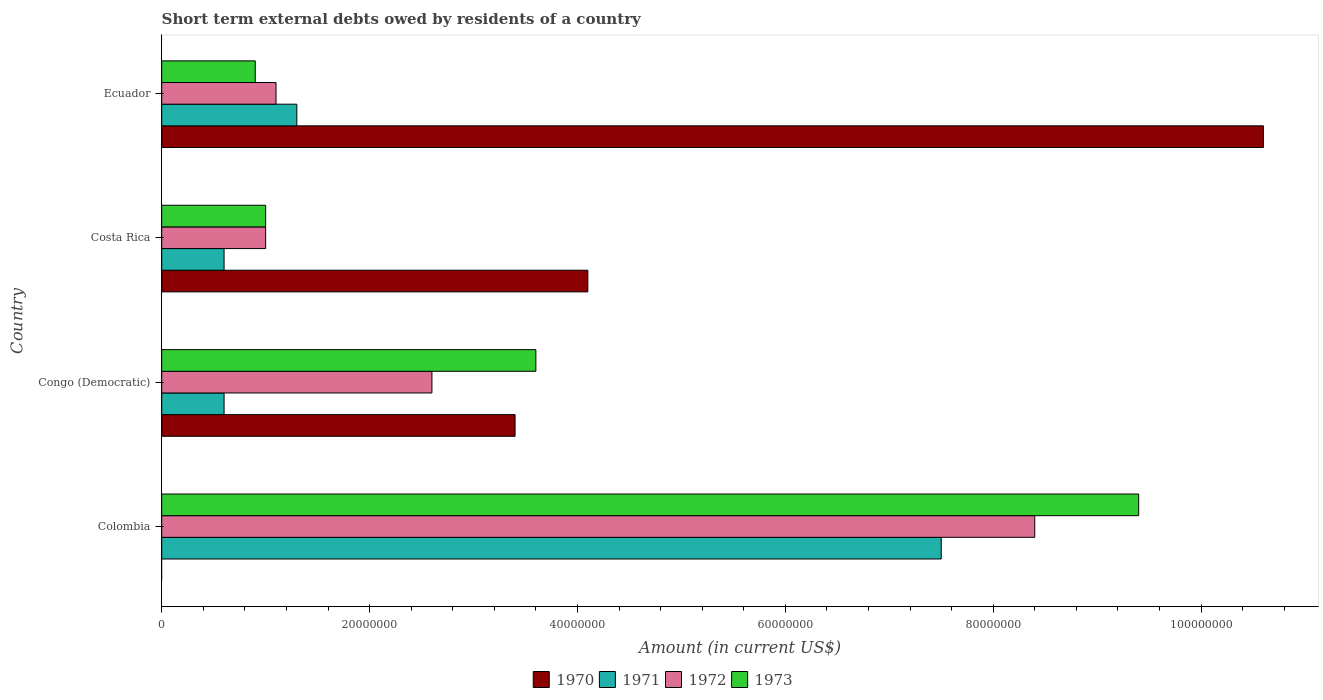How many groups of bars are there?
Provide a short and direct response. 4. What is the label of the 1st group of bars from the top?
Give a very brief answer. Ecuador. What is the amount of short-term external debts owed by residents in 1971 in Ecuador?
Your answer should be very brief. 1.30e+07. Across all countries, what is the maximum amount of short-term external debts owed by residents in 1970?
Provide a short and direct response. 1.06e+08. In which country was the amount of short-term external debts owed by residents in 1973 maximum?
Make the answer very short. Colombia. What is the total amount of short-term external debts owed by residents in 1970 in the graph?
Offer a very short reply. 1.81e+08. What is the difference between the amount of short-term external debts owed by residents in 1970 in Costa Rica and that in Ecuador?
Make the answer very short. -6.50e+07. What is the difference between the amount of short-term external debts owed by residents in 1973 in Colombia and the amount of short-term external debts owed by residents in 1972 in Costa Rica?
Provide a succinct answer. 8.40e+07. What is the average amount of short-term external debts owed by residents in 1971 per country?
Your response must be concise. 2.50e+07. What is the difference between the amount of short-term external debts owed by residents in 1971 and amount of short-term external debts owed by residents in 1970 in Congo (Democratic)?
Your response must be concise. -2.80e+07. In how many countries, is the amount of short-term external debts owed by residents in 1970 greater than 44000000 US$?
Your answer should be very brief. 1. What is the ratio of the amount of short-term external debts owed by residents in 1970 in Congo (Democratic) to that in Costa Rica?
Provide a succinct answer. 0.83. Is the difference between the amount of short-term external debts owed by residents in 1971 in Congo (Democratic) and Costa Rica greater than the difference between the amount of short-term external debts owed by residents in 1970 in Congo (Democratic) and Costa Rica?
Provide a succinct answer. Yes. What is the difference between the highest and the second highest amount of short-term external debts owed by residents in 1971?
Offer a terse response. 6.20e+07. What is the difference between the highest and the lowest amount of short-term external debts owed by residents in 1971?
Give a very brief answer. 6.90e+07. Is it the case that in every country, the sum of the amount of short-term external debts owed by residents in 1971 and amount of short-term external debts owed by residents in 1972 is greater than the sum of amount of short-term external debts owed by residents in 1970 and amount of short-term external debts owed by residents in 1973?
Offer a terse response. No. How many bars are there?
Offer a terse response. 15. How many countries are there in the graph?
Give a very brief answer. 4. What is the difference between two consecutive major ticks on the X-axis?
Give a very brief answer. 2.00e+07. Are the values on the major ticks of X-axis written in scientific E-notation?
Keep it short and to the point. No. Does the graph contain grids?
Give a very brief answer. No. Where does the legend appear in the graph?
Ensure brevity in your answer.  Bottom center. How many legend labels are there?
Your answer should be very brief. 4. How are the legend labels stacked?
Your answer should be compact. Horizontal. What is the title of the graph?
Offer a very short reply. Short term external debts owed by residents of a country. What is the label or title of the X-axis?
Provide a succinct answer. Amount (in current US$). What is the Amount (in current US$) of 1970 in Colombia?
Your response must be concise. 0. What is the Amount (in current US$) of 1971 in Colombia?
Offer a very short reply. 7.50e+07. What is the Amount (in current US$) in 1972 in Colombia?
Ensure brevity in your answer.  8.40e+07. What is the Amount (in current US$) of 1973 in Colombia?
Offer a very short reply. 9.40e+07. What is the Amount (in current US$) in 1970 in Congo (Democratic)?
Provide a short and direct response. 3.40e+07. What is the Amount (in current US$) of 1971 in Congo (Democratic)?
Give a very brief answer. 6.00e+06. What is the Amount (in current US$) in 1972 in Congo (Democratic)?
Keep it short and to the point. 2.60e+07. What is the Amount (in current US$) in 1973 in Congo (Democratic)?
Your response must be concise. 3.60e+07. What is the Amount (in current US$) of 1970 in Costa Rica?
Provide a succinct answer. 4.10e+07. What is the Amount (in current US$) of 1972 in Costa Rica?
Provide a succinct answer. 1.00e+07. What is the Amount (in current US$) in 1970 in Ecuador?
Ensure brevity in your answer.  1.06e+08. What is the Amount (in current US$) of 1971 in Ecuador?
Keep it short and to the point. 1.30e+07. What is the Amount (in current US$) in 1972 in Ecuador?
Provide a short and direct response. 1.10e+07. What is the Amount (in current US$) of 1973 in Ecuador?
Ensure brevity in your answer.  9.00e+06. Across all countries, what is the maximum Amount (in current US$) in 1970?
Your answer should be very brief. 1.06e+08. Across all countries, what is the maximum Amount (in current US$) in 1971?
Ensure brevity in your answer.  7.50e+07. Across all countries, what is the maximum Amount (in current US$) of 1972?
Keep it short and to the point. 8.40e+07. Across all countries, what is the maximum Amount (in current US$) of 1973?
Offer a very short reply. 9.40e+07. Across all countries, what is the minimum Amount (in current US$) in 1973?
Offer a terse response. 9.00e+06. What is the total Amount (in current US$) of 1970 in the graph?
Your response must be concise. 1.81e+08. What is the total Amount (in current US$) in 1972 in the graph?
Offer a terse response. 1.31e+08. What is the total Amount (in current US$) in 1973 in the graph?
Provide a short and direct response. 1.49e+08. What is the difference between the Amount (in current US$) in 1971 in Colombia and that in Congo (Democratic)?
Ensure brevity in your answer.  6.90e+07. What is the difference between the Amount (in current US$) of 1972 in Colombia and that in Congo (Democratic)?
Your response must be concise. 5.80e+07. What is the difference between the Amount (in current US$) in 1973 in Colombia and that in Congo (Democratic)?
Ensure brevity in your answer.  5.80e+07. What is the difference between the Amount (in current US$) in 1971 in Colombia and that in Costa Rica?
Offer a terse response. 6.90e+07. What is the difference between the Amount (in current US$) of 1972 in Colombia and that in Costa Rica?
Give a very brief answer. 7.40e+07. What is the difference between the Amount (in current US$) of 1973 in Colombia and that in Costa Rica?
Your answer should be compact. 8.40e+07. What is the difference between the Amount (in current US$) of 1971 in Colombia and that in Ecuador?
Your answer should be very brief. 6.20e+07. What is the difference between the Amount (in current US$) in 1972 in Colombia and that in Ecuador?
Ensure brevity in your answer.  7.30e+07. What is the difference between the Amount (in current US$) of 1973 in Colombia and that in Ecuador?
Ensure brevity in your answer.  8.50e+07. What is the difference between the Amount (in current US$) in 1970 in Congo (Democratic) and that in Costa Rica?
Provide a short and direct response. -7.00e+06. What is the difference between the Amount (in current US$) of 1971 in Congo (Democratic) and that in Costa Rica?
Ensure brevity in your answer.  0. What is the difference between the Amount (in current US$) in 1972 in Congo (Democratic) and that in Costa Rica?
Provide a short and direct response. 1.60e+07. What is the difference between the Amount (in current US$) in 1973 in Congo (Democratic) and that in Costa Rica?
Provide a succinct answer. 2.60e+07. What is the difference between the Amount (in current US$) in 1970 in Congo (Democratic) and that in Ecuador?
Your answer should be very brief. -7.20e+07. What is the difference between the Amount (in current US$) in 1971 in Congo (Democratic) and that in Ecuador?
Provide a succinct answer. -7.00e+06. What is the difference between the Amount (in current US$) in 1972 in Congo (Democratic) and that in Ecuador?
Provide a short and direct response. 1.50e+07. What is the difference between the Amount (in current US$) in 1973 in Congo (Democratic) and that in Ecuador?
Keep it short and to the point. 2.70e+07. What is the difference between the Amount (in current US$) of 1970 in Costa Rica and that in Ecuador?
Provide a succinct answer. -6.50e+07. What is the difference between the Amount (in current US$) of 1971 in Costa Rica and that in Ecuador?
Offer a very short reply. -7.00e+06. What is the difference between the Amount (in current US$) of 1972 in Costa Rica and that in Ecuador?
Keep it short and to the point. -1.00e+06. What is the difference between the Amount (in current US$) in 1973 in Costa Rica and that in Ecuador?
Give a very brief answer. 1.00e+06. What is the difference between the Amount (in current US$) in 1971 in Colombia and the Amount (in current US$) in 1972 in Congo (Democratic)?
Provide a succinct answer. 4.90e+07. What is the difference between the Amount (in current US$) in 1971 in Colombia and the Amount (in current US$) in 1973 in Congo (Democratic)?
Make the answer very short. 3.90e+07. What is the difference between the Amount (in current US$) in 1972 in Colombia and the Amount (in current US$) in 1973 in Congo (Democratic)?
Provide a short and direct response. 4.80e+07. What is the difference between the Amount (in current US$) of 1971 in Colombia and the Amount (in current US$) of 1972 in Costa Rica?
Provide a succinct answer. 6.50e+07. What is the difference between the Amount (in current US$) of 1971 in Colombia and the Amount (in current US$) of 1973 in Costa Rica?
Provide a short and direct response. 6.50e+07. What is the difference between the Amount (in current US$) in 1972 in Colombia and the Amount (in current US$) in 1973 in Costa Rica?
Offer a very short reply. 7.40e+07. What is the difference between the Amount (in current US$) in 1971 in Colombia and the Amount (in current US$) in 1972 in Ecuador?
Offer a terse response. 6.40e+07. What is the difference between the Amount (in current US$) in 1971 in Colombia and the Amount (in current US$) in 1973 in Ecuador?
Ensure brevity in your answer.  6.60e+07. What is the difference between the Amount (in current US$) in 1972 in Colombia and the Amount (in current US$) in 1973 in Ecuador?
Offer a very short reply. 7.50e+07. What is the difference between the Amount (in current US$) in 1970 in Congo (Democratic) and the Amount (in current US$) in 1971 in Costa Rica?
Provide a succinct answer. 2.80e+07. What is the difference between the Amount (in current US$) of 1970 in Congo (Democratic) and the Amount (in current US$) of 1972 in Costa Rica?
Make the answer very short. 2.40e+07. What is the difference between the Amount (in current US$) of 1970 in Congo (Democratic) and the Amount (in current US$) of 1973 in Costa Rica?
Give a very brief answer. 2.40e+07. What is the difference between the Amount (in current US$) of 1971 in Congo (Democratic) and the Amount (in current US$) of 1972 in Costa Rica?
Your answer should be compact. -4.00e+06. What is the difference between the Amount (in current US$) in 1972 in Congo (Democratic) and the Amount (in current US$) in 1973 in Costa Rica?
Offer a very short reply. 1.60e+07. What is the difference between the Amount (in current US$) of 1970 in Congo (Democratic) and the Amount (in current US$) of 1971 in Ecuador?
Provide a succinct answer. 2.10e+07. What is the difference between the Amount (in current US$) of 1970 in Congo (Democratic) and the Amount (in current US$) of 1972 in Ecuador?
Offer a terse response. 2.30e+07. What is the difference between the Amount (in current US$) of 1970 in Congo (Democratic) and the Amount (in current US$) of 1973 in Ecuador?
Offer a very short reply. 2.50e+07. What is the difference between the Amount (in current US$) in 1971 in Congo (Democratic) and the Amount (in current US$) in 1972 in Ecuador?
Offer a terse response. -5.00e+06. What is the difference between the Amount (in current US$) of 1972 in Congo (Democratic) and the Amount (in current US$) of 1973 in Ecuador?
Your response must be concise. 1.70e+07. What is the difference between the Amount (in current US$) of 1970 in Costa Rica and the Amount (in current US$) of 1971 in Ecuador?
Your response must be concise. 2.80e+07. What is the difference between the Amount (in current US$) in 1970 in Costa Rica and the Amount (in current US$) in 1972 in Ecuador?
Ensure brevity in your answer.  3.00e+07. What is the difference between the Amount (in current US$) in 1970 in Costa Rica and the Amount (in current US$) in 1973 in Ecuador?
Your answer should be compact. 3.20e+07. What is the difference between the Amount (in current US$) in 1971 in Costa Rica and the Amount (in current US$) in 1972 in Ecuador?
Offer a terse response. -5.00e+06. What is the average Amount (in current US$) of 1970 per country?
Offer a terse response. 4.52e+07. What is the average Amount (in current US$) of 1971 per country?
Give a very brief answer. 2.50e+07. What is the average Amount (in current US$) of 1972 per country?
Give a very brief answer. 3.28e+07. What is the average Amount (in current US$) in 1973 per country?
Your response must be concise. 3.72e+07. What is the difference between the Amount (in current US$) of 1971 and Amount (in current US$) of 1972 in Colombia?
Provide a short and direct response. -9.00e+06. What is the difference between the Amount (in current US$) in 1971 and Amount (in current US$) in 1973 in Colombia?
Your answer should be very brief. -1.90e+07. What is the difference between the Amount (in current US$) in 1972 and Amount (in current US$) in 1973 in Colombia?
Give a very brief answer. -1.00e+07. What is the difference between the Amount (in current US$) of 1970 and Amount (in current US$) of 1971 in Congo (Democratic)?
Ensure brevity in your answer.  2.80e+07. What is the difference between the Amount (in current US$) in 1970 and Amount (in current US$) in 1972 in Congo (Democratic)?
Offer a very short reply. 8.00e+06. What is the difference between the Amount (in current US$) in 1970 and Amount (in current US$) in 1973 in Congo (Democratic)?
Ensure brevity in your answer.  -2.00e+06. What is the difference between the Amount (in current US$) in 1971 and Amount (in current US$) in 1972 in Congo (Democratic)?
Provide a short and direct response. -2.00e+07. What is the difference between the Amount (in current US$) in 1971 and Amount (in current US$) in 1973 in Congo (Democratic)?
Your answer should be very brief. -3.00e+07. What is the difference between the Amount (in current US$) in 1972 and Amount (in current US$) in 1973 in Congo (Democratic)?
Make the answer very short. -1.00e+07. What is the difference between the Amount (in current US$) in 1970 and Amount (in current US$) in 1971 in Costa Rica?
Offer a very short reply. 3.50e+07. What is the difference between the Amount (in current US$) in 1970 and Amount (in current US$) in 1972 in Costa Rica?
Keep it short and to the point. 3.10e+07. What is the difference between the Amount (in current US$) in 1970 and Amount (in current US$) in 1973 in Costa Rica?
Offer a very short reply. 3.10e+07. What is the difference between the Amount (in current US$) in 1971 and Amount (in current US$) in 1972 in Costa Rica?
Keep it short and to the point. -4.00e+06. What is the difference between the Amount (in current US$) of 1972 and Amount (in current US$) of 1973 in Costa Rica?
Your response must be concise. 0. What is the difference between the Amount (in current US$) in 1970 and Amount (in current US$) in 1971 in Ecuador?
Offer a very short reply. 9.30e+07. What is the difference between the Amount (in current US$) in 1970 and Amount (in current US$) in 1972 in Ecuador?
Your answer should be compact. 9.50e+07. What is the difference between the Amount (in current US$) in 1970 and Amount (in current US$) in 1973 in Ecuador?
Your answer should be very brief. 9.70e+07. What is the difference between the Amount (in current US$) of 1971 and Amount (in current US$) of 1972 in Ecuador?
Provide a short and direct response. 2.00e+06. What is the ratio of the Amount (in current US$) in 1971 in Colombia to that in Congo (Democratic)?
Offer a very short reply. 12.5. What is the ratio of the Amount (in current US$) in 1972 in Colombia to that in Congo (Democratic)?
Give a very brief answer. 3.23. What is the ratio of the Amount (in current US$) in 1973 in Colombia to that in Congo (Democratic)?
Ensure brevity in your answer.  2.61. What is the ratio of the Amount (in current US$) in 1971 in Colombia to that in Costa Rica?
Keep it short and to the point. 12.5. What is the ratio of the Amount (in current US$) of 1972 in Colombia to that in Costa Rica?
Offer a terse response. 8.4. What is the ratio of the Amount (in current US$) in 1973 in Colombia to that in Costa Rica?
Provide a short and direct response. 9.4. What is the ratio of the Amount (in current US$) in 1971 in Colombia to that in Ecuador?
Offer a very short reply. 5.77. What is the ratio of the Amount (in current US$) in 1972 in Colombia to that in Ecuador?
Offer a very short reply. 7.64. What is the ratio of the Amount (in current US$) in 1973 in Colombia to that in Ecuador?
Your answer should be compact. 10.44. What is the ratio of the Amount (in current US$) in 1970 in Congo (Democratic) to that in Costa Rica?
Give a very brief answer. 0.83. What is the ratio of the Amount (in current US$) in 1971 in Congo (Democratic) to that in Costa Rica?
Offer a very short reply. 1. What is the ratio of the Amount (in current US$) of 1973 in Congo (Democratic) to that in Costa Rica?
Provide a short and direct response. 3.6. What is the ratio of the Amount (in current US$) of 1970 in Congo (Democratic) to that in Ecuador?
Give a very brief answer. 0.32. What is the ratio of the Amount (in current US$) of 1971 in Congo (Democratic) to that in Ecuador?
Give a very brief answer. 0.46. What is the ratio of the Amount (in current US$) in 1972 in Congo (Democratic) to that in Ecuador?
Offer a very short reply. 2.36. What is the ratio of the Amount (in current US$) in 1970 in Costa Rica to that in Ecuador?
Provide a short and direct response. 0.39. What is the ratio of the Amount (in current US$) in 1971 in Costa Rica to that in Ecuador?
Provide a succinct answer. 0.46. What is the ratio of the Amount (in current US$) of 1973 in Costa Rica to that in Ecuador?
Keep it short and to the point. 1.11. What is the difference between the highest and the second highest Amount (in current US$) of 1970?
Your response must be concise. 6.50e+07. What is the difference between the highest and the second highest Amount (in current US$) of 1971?
Offer a very short reply. 6.20e+07. What is the difference between the highest and the second highest Amount (in current US$) in 1972?
Your response must be concise. 5.80e+07. What is the difference between the highest and the second highest Amount (in current US$) of 1973?
Keep it short and to the point. 5.80e+07. What is the difference between the highest and the lowest Amount (in current US$) of 1970?
Provide a short and direct response. 1.06e+08. What is the difference between the highest and the lowest Amount (in current US$) in 1971?
Offer a terse response. 6.90e+07. What is the difference between the highest and the lowest Amount (in current US$) of 1972?
Your response must be concise. 7.40e+07. What is the difference between the highest and the lowest Amount (in current US$) of 1973?
Your answer should be very brief. 8.50e+07. 